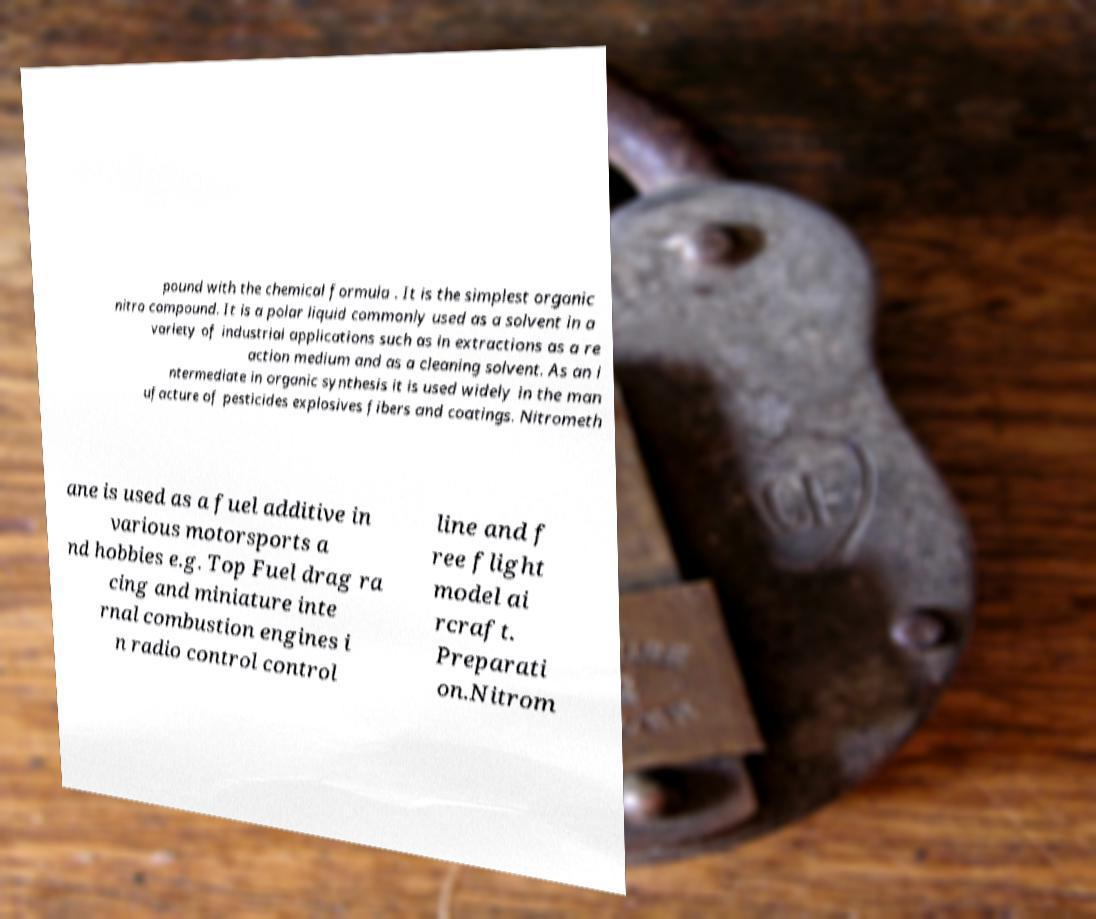What messages or text are displayed in this image? I need them in a readable, typed format. pound with the chemical formula . It is the simplest organic nitro compound. It is a polar liquid commonly used as a solvent in a variety of industrial applications such as in extractions as a re action medium and as a cleaning solvent. As an i ntermediate in organic synthesis it is used widely in the man ufacture of pesticides explosives fibers and coatings. Nitrometh ane is used as a fuel additive in various motorsports a nd hobbies e.g. Top Fuel drag ra cing and miniature inte rnal combustion engines i n radio control control line and f ree flight model ai rcraft. Preparati on.Nitrom 